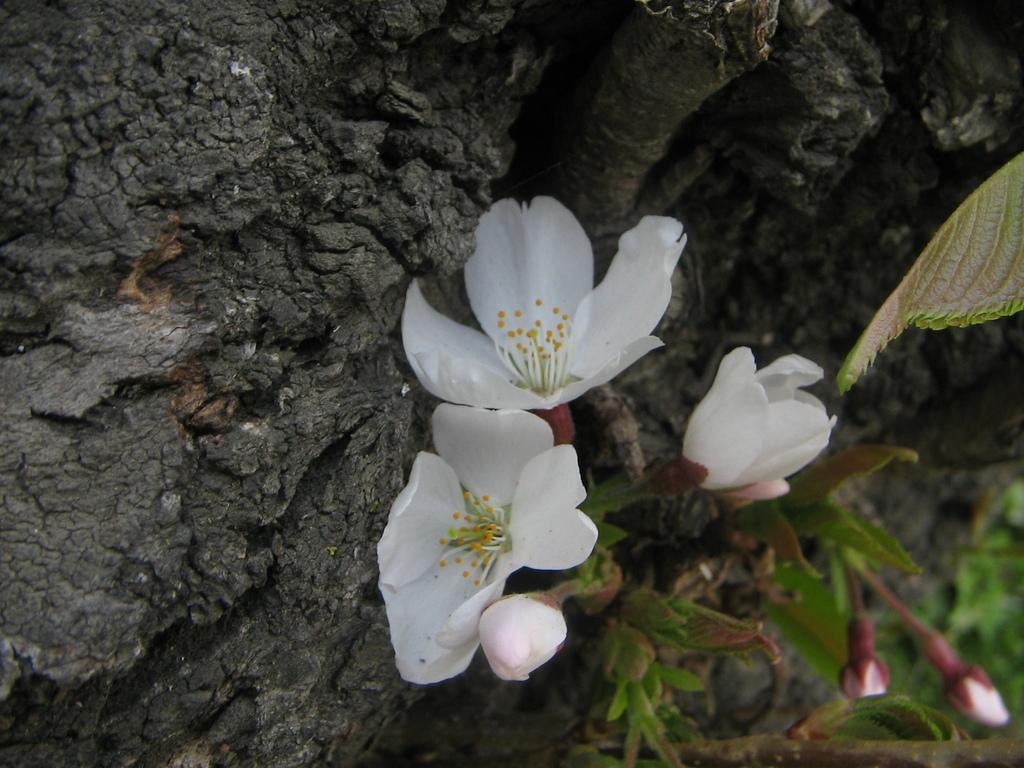Could you give a brief overview of what you see in this image? This picture is clicked outside. In the center we can see the white color flowers. On the right there is a plant and we can see the buds. In the background there is a rock. 